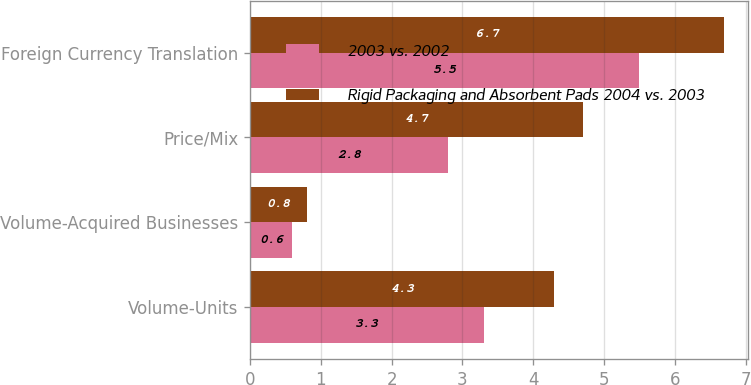<chart> <loc_0><loc_0><loc_500><loc_500><stacked_bar_chart><ecel><fcel>Volume-Units<fcel>Volume-Acquired Businesses<fcel>Price/Mix<fcel>Foreign Currency Translation<nl><fcel>2003 vs. 2002<fcel>3.3<fcel>0.6<fcel>2.8<fcel>5.5<nl><fcel>Rigid Packaging and Absorbent Pads 2004 vs. 2003<fcel>4.3<fcel>0.8<fcel>4.7<fcel>6.7<nl></chart> 